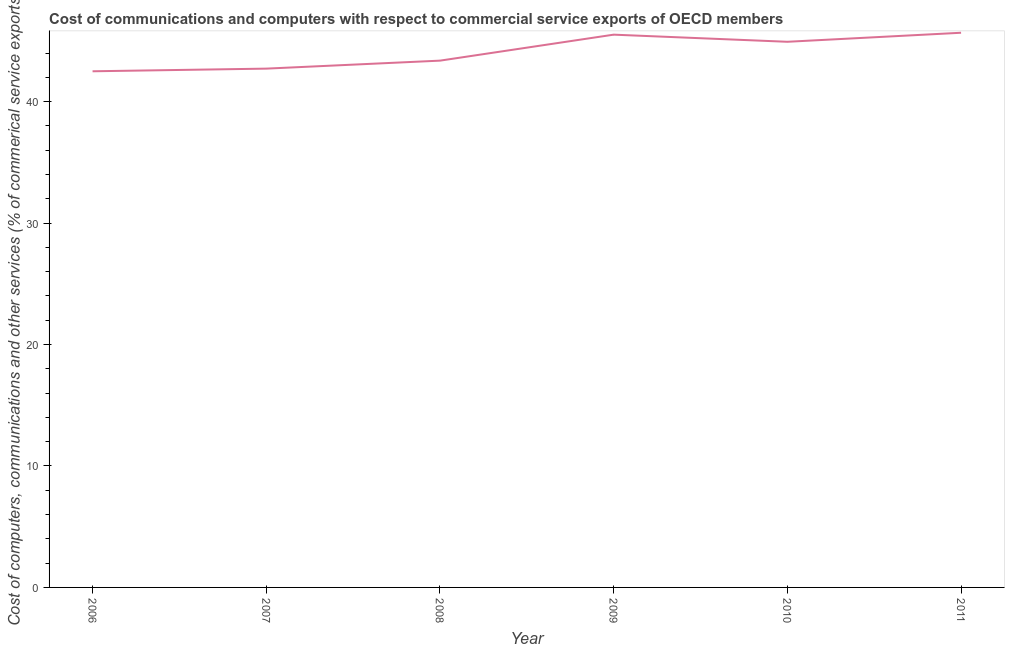What is the  computer and other services in 2008?
Your answer should be compact. 43.37. Across all years, what is the maximum  computer and other services?
Make the answer very short. 45.67. Across all years, what is the minimum cost of communications?
Provide a succinct answer. 42.5. In which year was the cost of communications minimum?
Give a very brief answer. 2006. What is the sum of the cost of communications?
Keep it short and to the point. 264.69. What is the difference between the  computer and other services in 2008 and 2011?
Offer a very short reply. -2.3. What is the average  computer and other services per year?
Offer a very short reply. 44.12. What is the median cost of communications?
Your answer should be compact. 44.15. Do a majority of the years between 2010 and 2006 (inclusive) have  computer and other services greater than 22 %?
Your answer should be compact. Yes. What is the ratio of the cost of communications in 2008 to that in 2011?
Your answer should be compact. 0.95. What is the difference between the highest and the second highest cost of communications?
Offer a terse response. 0.16. Is the sum of the cost of communications in 2007 and 2008 greater than the maximum cost of communications across all years?
Provide a short and direct response. Yes. What is the difference between the highest and the lowest  computer and other services?
Offer a very short reply. 3.17. Does the cost of communications monotonically increase over the years?
Ensure brevity in your answer.  No. How many lines are there?
Your answer should be compact. 1. How many years are there in the graph?
Ensure brevity in your answer.  6. What is the difference between two consecutive major ticks on the Y-axis?
Your answer should be very brief. 10. What is the title of the graph?
Provide a short and direct response. Cost of communications and computers with respect to commercial service exports of OECD members. What is the label or title of the X-axis?
Ensure brevity in your answer.  Year. What is the label or title of the Y-axis?
Keep it short and to the point. Cost of computers, communications and other services (% of commerical service exports). What is the Cost of computers, communications and other services (% of commerical service exports) in 2006?
Offer a terse response. 42.5. What is the Cost of computers, communications and other services (% of commerical service exports) of 2007?
Your answer should be very brief. 42.72. What is the Cost of computers, communications and other services (% of commerical service exports) in 2008?
Offer a very short reply. 43.37. What is the Cost of computers, communications and other services (% of commerical service exports) in 2009?
Provide a short and direct response. 45.51. What is the Cost of computers, communications and other services (% of commerical service exports) of 2010?
Your answer should be compact. 44.93. What is the Cost of computers, communications and other services (% of commerical service exports) in 2011?
Make the answer very short. 45.67. What is the difference between the Cost of computers, communications and other services (% of commerical service exports) in 2006 and 2007?
Offer a very short reply. -0.22. What is the difference between the Cost of computers, communications and other services (% of commerical service exports) in 2006 and 2008?
Give a very brief answer. -0.88. What is the difference between the Cost of computers, communications and other services (% of commerical service exports) in 2006 and 2009?
Offer a very short reply. -3.02. What is the difference between the Cost of computers, communications and other services (% of commerical service exports) in 2006 and 2010?
Provide a short and direct response. -2.43. What is the difference between the Cost of computers, communications and other services (% of commerical service exports) in 2006 and 2011?
Offer a very short reply. -3.17. What is the difference between the Cost of computers, communications and other services (% of commerical service exports) in 2007 and 2008?
Ensure brevity in your answer.  -0.66. What is the difference between the Cost of computers, communications and other services (% of commerical service exports) in 2007 and 2009?
Your answer should be very brief. -2.8. What is the difference between the Cost of computers, communications and other services (% of commerical service exports) in 2007 and 2010?
Provide a short and direct response. -2.21. What is the difference between the Cost of computers, communications and other services (% of commerical service exports) in 2007 and 2011?
Provide a short and direct response. -2.95. What is the difference between the Cost of computers, communications and other services (% of commerical service exports) in 2008 and 2009?
Ensure brevity in your answer.  -2.14. What is the difference between the Cost of computers, communications and other services (% of commerical service exports) in 2008 and 2010?
Keep it short and to the point. -1.55. What is the difference between the Cost of computers, communications and other services (% of commerical service exports) in 2008 and 2011?
Offer a terse response. -2.3. What is the difference between the Cost of computers, communications and other services (% of commerical service exports) in 2009 and 2010?
Your answer should be very brief. 0.59. What is the difference between the Cost of computers, communications and other services (% of commerical service exports) in 2009 and 2011?
Offer a very short reply. -0.16. What is the difference between the Cost of computers, communications and other services (% of commerical service exports) in 2010 and 2011?
Your answer should be very brief. -0.74. What is the ratio of the Cost of computers, communications and other services (% of commerical service exports) in 2006 to that in 2009?
Your answer should be compact. 0.93. What is the ratio of the Cost of computers, communications and other services (% of commerical service exports) in 2006 to that in 2010?
Provide a succinct answer. 0.95. What is the ratio of the Cost of computers, communications and other services (% of commerical service exports) in 2006 to that in 2011?
Your answer should be very brief. 0.93. What is the ratio of the Cost of computers, communications and other services (% of commerical service exports) in 2007 to that in 2009?
Your answer should be compact. 0.94. What is the ratio of the Cost of computers, communications and other services (% of commerical service exports) in 2007 to that in 2010?
Offer a very short reply. 0.95. What is the ratio of the Cost of computers, communications and other services (% of commerical service exports) in 2007 to that in 2011?
Your response must be concise. 0.94. What is the ratio of the Cost of computers, communications and other services (% of commerical service exports) in 2008 to that in 2009?
Provide a short and direct response. 0.95. What is the ratio of the Cost of computers, communications and other services (% of commerical service exports) in 2008 to that in 2010?
Keep it short and to the point. 0.96. What is the ratio of the Cost of computers, communications and other services (% of commerical service exports) in 2009 to that in 2011?
Give a very brief answer. 1. 